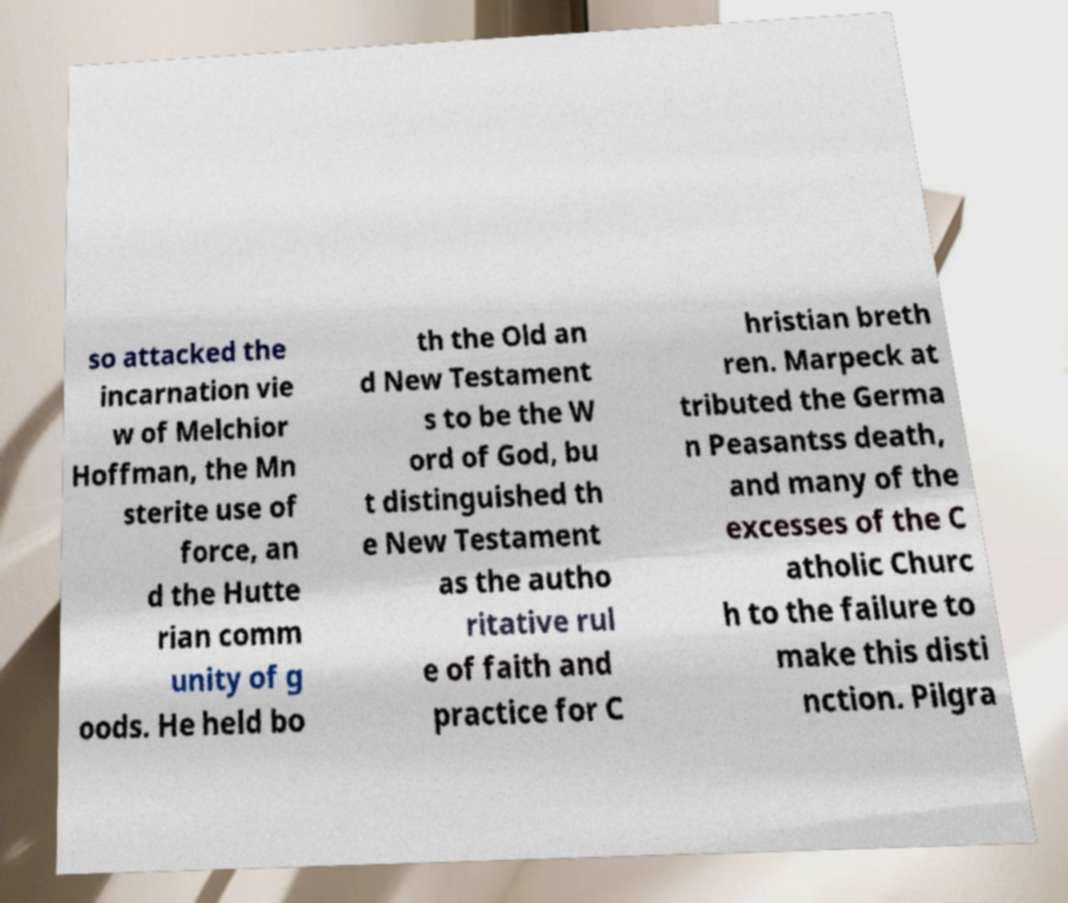Please identify and transcribe the text found in this image. so attacked the incarnation vie w of Melchior Hoffman, the Mn sterite use of force, an d the Hutte rian comm unity of g oods. He held bo th the Old an d New Testament s to be the W ord of God, bu t distinguished th e New Testament as the autho ritative rul e of faith and practice for C hristian breth ren. Marpeck at tributed the Germa n Peasantss death, and many of the excesses of the C atholic Churc h to the failure to make this disti nction. Pilgra 